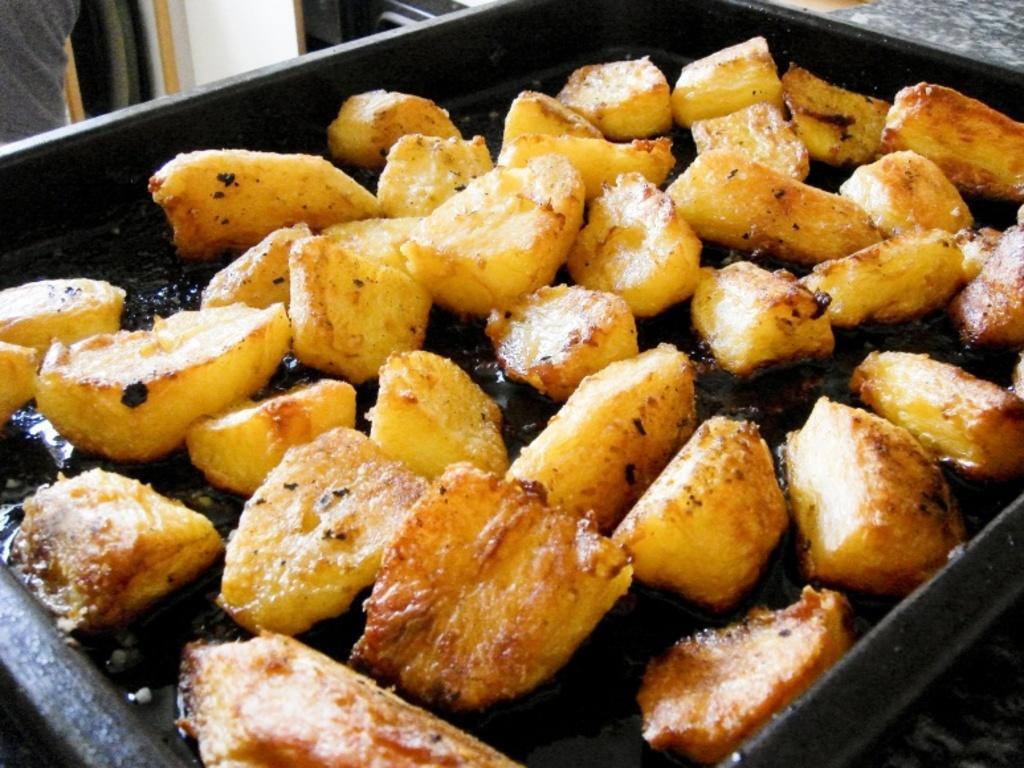How would you summarize this image in a sentence or two? In this image there is a tray on that tree there is food item. 